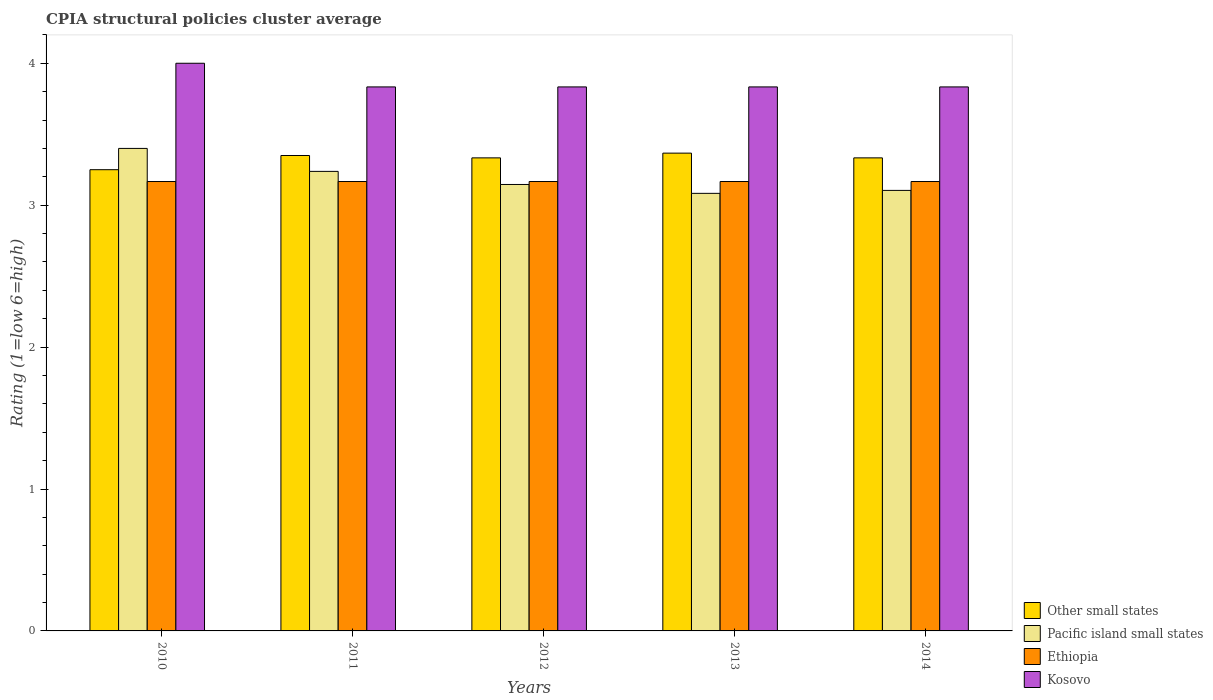How many different coloured bars are there?
Provide a short and direct response. 4. How many groups of bars are there?
Your answer should be compact. 5. How many bars are there on the 4th tick from the right?
Your answer should be compact. 4. What is the label of the 3rd group of bars from the left?
Your answer should be very brief. 2012. In how many cases, is the number of bars for a given year not equal to the number of legend labels?
Your answer should be compact. 0. What is the CPIA rating in Other small states in 2012?
Provide a succinct answer. 3.33. Across all years, what is the maximum CPIA rating in Kosovo?
Your answer should be very brief. 4. Across all years, what is the minimum CPIA rating in Pacific island small states?
Ensure brevity in your answer.  3.08. In which year was the CPIA rating in Ethiopia minimum?
Make the answer very short. 2010. What is the total CPIA rating in Other small states in the graph?
Your answer should be compact. 16.63. What is the difference between the CPIA rating in Ethiopia in 2011 and the CPIA rating in Kosovo in 2012?
Your answer should be very brief. -0.67. What is the average CPIA rating in Other small states per year?
Keep it short and to the point. 3.33. In the year 2011, what is the difference between the CPIA rating in Ethiopia and CPIA rating in Pacific island small states?
Provide a succinct answer. -0.07. In how many years, is the CPIA rating in Kosovo greater than 1.4?
Offer a terse response. 5. What is the ratio of the CPIA rating in Pacific island small states in 2012 to that in 2013?
Give a very brief answer. 1.02. Is the difference between the CPIA rating in Ethiopia in 2010 and 2013 greater than the difference between the CPIA rating in Pacific island small states in 2010 and 2013?
Give a very brief answer. No. What is the difference between the highest and the lowest CPIA rating in Kosovo?
Your answer should be very brief. 0.17. In how many years, is the CPIA rating in Kosovo greater than the average CPIA rating in Kosovo taken over all years?
Offer a very short reply. 1. Is the sum of the CPIA rating in Kosovo in 2011 and 2014 greater than the maximum CPIA rating in Ethiopia across all years?
Offer a very short reply. Yes. What does the 1st bar from the left in 2014 represents?
Make the answer very short. Other small states. What does the 1st bar from the right in 2012 represents?
Offer a terse response. Kosovo. Is it the case that in every year, the sum of the CPIA rating in Other small states and CPIA rating in Kosovo is greater than the CPIA rating in Ethiopia?
Offer a terse response. Yes. How many bars are there?
Offer a very short reply. 20. What is the difference between two consecutive major ticks on the Y-axis?
Your answer should be very brief. 1. Are the values on the major ticks of Y-axis written in scientific E-notation?
Make the answer very short. No. Does the graph contain grids?
Your answer should be very brief. No. Where does the legend appear in the graph?
Your response must be concise. Bottom right. How many legend labels are there?
Give a very brief answer. 4. How are the legend labels stacked?
Give a very brief answer. Vertical. What is the title of the graph?
Offer a very short reply. CPIA structural policies cluster average. Does "Congo (Democratic)" appear as one of the legend labels in the graph?
Make the answer very short. No. What is the label or title of the Y-axis?
Offer a terse response. Rating (1=low 6=high). What is the Rating (1=low 6=high) in Other small states in 2010?
Make the answer very short. 3.25. What is the Rating (1=low 6=high) of Ethiopia in 2010?
Ensure brevity in your answer.  3.17. What is the Rating (1=low 6=high) of Kosovo in 2010?
Ensure brevity in your answer.  4. What is the Rating (1=low 6=high) of Other small states in 2011?
Your answer should be compact. 3.35. What is the Rating (1=low 6=high) of Pacific island small states in 2011?
Provide a short and direct response. 3.24. What is the Rating (1=low 6=high) of Ethiopia in 2011?
Offer a terse response. 3.17. What is the Rating (1=low 6=high) of Kosovo in 2011?
Give a very brief answer. 3.83. What is the Rating (1=low 6=high) of Other small states in 2012?
Make the answer very short. 3.33. What is the Rating (1=low 6=high) in Pacific island small states in 2012?
Your response must be concise. 3.15. What is the Rating (1=low 6=high) in Ethiopia in 2012?
Your answer should be very brief. 3.17. What is the Rating (1=low 6=high) of Kosovo in 2012?
Provide a succinct answer. 3.83. What is the Rating (1=low 6=high) in Other small states in 2013?
Your response must be concise. 3.37. What is the Rating (1=low 6=high) of Pacific island small states in 2013?
Your answer should be very brief. 3.08. What is the Rating (1=low 6=high) in Ethiopia in 2013?
Keep it short and to the point. 3.17. What is the Rating (1=low 6=high) of Kosovo in 2013?
Offer a terse response. 3.83. What is the Rating (1=low 6=high) of Other small states in 2014?
Ensure brevity in your answer.  3.33. What is the Rating (1=low 6=high) in Pacific island small states in 2014?
Keep it short and to the point. 3.1. What is the Rating (1=low 6=high) in Ethiopia in 2014?
Offer a very short reply. 3.17. What is the Rating (1=low 6=high) in Kosovo in 2014?
Provide a short and direct response. 3.83. Across all years, what is the maximum Rating (1=low 6=high) in Other small states?
Your answer should be very brief. 3.37. Across all years, what is the maximum Rating (1=low 6=high) in Pacific island small states?
Offer a terse response. 3.4. Across all years, what is the maximum Rating (1=low 6=high) in Ethiopia?
Give a very brief answer. 3.17. Across all years, what is the minimum Rating (1=low 6=high) in Other small states?
Make the answer very short. 3.25. Across all years, what is the minimum Rating (1=low 6=high) of Pacific island small states?
Offer a terse response. 3.08. Across all years, what is the minimum Rating (1=low 6=high) of Ethiopia?
Offer a very short reply. 3.17. Across all years, what is the minimum Rating (1=low 6=high) of Kosovo?
Offer a terse response. 3.83. What is the total Rating (1=low 6=high) in Other small states in the graph?
Provide a succinct answer. 16.63. What is the total Rating (1=low 6=high) in Pacific island small states in the graph?
Offer a very short reply. 15.97. What is the total Rating (1=low 6=high) of Ethiopia in the graph?
Keep it short and to the point. 15.83. What is the total Rating (1=low 6=high) in Kosovo in the graph?
Make the answer very short. 19.33. What is the difference between the Rating (1=low 6=high) of Pacific island small states in 2010 and that in 2011?
Give a very brief answer. 0.16. What is the difference between the Rating (1=low 6=high) in Other small states in 2010 and that in 2012?
Ensure brevity in your answer.  -0.08. What is the difference between the Rating (1=low 6=high) in Pacific island small states in 2010 and that in 2012?
Your response must be concise. 0.25. What is the difference between the Rating (1=low 6=high) in Kosovo in 2010 and that in 2012?
Keep it short and to the point. 0.17. What is the difference between the Rating (1=low 6=high) of Other small states in 2010 and that in 2013?
Offer a terse response. -0.12. What is the difference between the Rating (1=low 6=high) in Pacific island small states in 2010 and that in 2013?
Provide a short and direct response. 0.32. What is the difference between the Rating (1=low 6=high) in Kosovo in 2010 and that in 2013?
Offer a very short reply. 0.17. What is the difference between the Rating (1=low 6=high) in Other small states in 2010 and that in 2014?
Offer a terse response. -0.08. What is the difference between the Rating (1=low 6=high) in Pacific island small states in 2010 and that in 2014?
Provide a short and direct response. 0.3. What is the difference between the Rating (1=low 6=high) of Kosovo in 2010 and that in 2014?
Provide a short and direct response. 0.17. What is the difference between the Rating (1=low 6=high) in Other small states in 2011 and that in 2012?
Offer a terse response. 0.02. What is the difference between the Rating (1=low 6=high) of Pacific island small states in 2011 and that in 2012?
Your answer should be compact. 0.09. What is the difference between the Rating (1=low 6=high) in Other small states in 2011 and that in 2013?
Offer a very short reply. -0.02. What is the difference between the Rating (1=low 6=high) in Pacific island small states in 2011 and that in 2013?
Ensure brevity in your answer.  0.15. What is the difference between the Rating (1=low 6=high) of Ethiopia in 2011 and that in 2013?
Your answer should be very brief. 0. What is the difference between the Rating (1=low 6=high) in Kosovo in 2011 and that in 2013?
Offer a very short reply. 0. What is the difference between the Rating (1=low 6=high) in Other small states in 2011 and that in 2014?
Offer a very short reply. 0.02. What is the difference between the Rating (1=low 6=high) in Pacific island small states in 2011 and that in 2014?
Your answer should be very brief. 0.13. What is the difference between the Rating (1=low 6=high) in Other small states in 2012 and that in 2013?
Offer a very short reply. -0.03. What is the difference between the Rating (1=low 6=high) of Pacific island small states in 2012 and that in 2013?
Offer a very short reply. 0.06. What is the difference between the Rating (1=low 6=high) of Ethiopia in 2012 and that in 2013?
Make the answer very short. 0. What is the difference between the Rating (1=low 6=high) of Kosovo in 2012 and that in 2013?
Ensure brevity in your answer.  0. What is the difference between the Rating (1=low 6=high) of Other small states in 2012 and that in 2014?
Your answer should be very brief. 0. What is the difference between the Rating (1=low 6=high) of Pacific island small states in 2012 and that in 2014?
Keep it short and to the point. 0.04. What is the difference between the Rating (1=low 6=high) in Ethiopia in 2012 and that in 2014?
Your answer should be compact. 0. What is the difference between the Rating (1=low 6=high) of Kosovo in 2012 and that in 2014?
Offer a very short reply. 0. What is the difference between the Rating (1=low 6=high) of Pacific island small states in 2013 and that in 2014?
Provide a short and direct response. -0.02. What is the difference between the Rating (1=low 6=high) in Other small states in 2010 and the Rating (1=low 6=high) in Pacific island small states in 2011?
Your answer should be very brief. 0.01. What is the difference between the Rating (1=low 6=high) of Other small states in 2010 and the Rating (1=low 6=high) of Ethiopia in 2011?
Provide a succinct answer. 0.08. What is the difference between the Rating (1=low 6=high) of Other small states in 2010 and the Rating (1=low 6=high) of Kosovo in 2011?
Your answer should be very brief. -0.58. What is the difference between the Rating (1=low 6=high) of Pacific island small states in 2010 and the Rating (1=low 6=high) of Ethiopia in 2011?
Your answer should be compact. 0.23. What is the difference between the Rating (1=low 6=high) in Pacific island small states in 2010 and the Rating (1=low 6=high) in Kosovo in 2011?
Keep it short and to the point. -0.43. What is the difference between the Rating (1=low 6=high) of Other small states in 2010 and the Rating (1=low 6=high) of Pacific island small states in 2012?
Offer a terse response. 0.1. What is the difference between the Rating (1=low 6=high) of Other small states in 2010 and the Rating (1=low 6=high) of Ethiopia in 2012?
Provide a short and direct response. 0.08. What is the difference between the Rating (1=low 6=high) of Other small states in 2010 and the Rating (1=low 6=high) of Kosovo in 2012?
Your answer should be very brief. -0.58. What is the difference between the Rating (1=low 6=high) of Pacific island small states in 2010 and the Rating (1=low 6=high) of Ethiopia in 2012?
Your answer should be very brief. 0.23. What is the difference between the Rating (1=low 6=high) of Pacific island small states in 2010 and the Rating (1=low 6=high) of Kosovo in 2012?
Provide a succinct answer. -0.43. What is the difference between the Rating (1=low 6=high) of Other small states in 2010 and the Rating (1=low 6=high) of Pacific island small states in 2013?
Your answer should be very brief. 0.17. What is the difference between the Rating (1=low 6=high) of Other small states in 2010 and the Rating (1=low 6=high) of Ethiopia in 2013?
Offer a very short reply. 0.08. What is the difference between the Rating (1=low 6=high) of Other small states in 2010 and the Rating (1=low 6=high) of Kosovo in 2013?
Make the answer very short. -0.58. What is the difference between the Rating (1=low 6=high) in Pacific island small states in 2010 and the Rating (1=low 6=high) in Ethiopia in 2013?
Keep it short and to the point. 0.23. What is the difference between the Rating (1=low 6=high) of Pacific island small states in 2010 and the Rating (1=low 6=high) of Kosovo in 2013?
Offer a terse response. -0.43. What is the difference between the Rating (1=low 6=high) of Other small states in 2010 and the Rating (1=low 6=high) of Pacific island small states in 2014?
Keep it short and to the point. 0.15. What is the difference between the Rating (1=low 6=high) of Other small states in 2010 and the Rating (1=low 6=high) of Ethiopia in 2014?
Provide a short and direct response. 0.08. What is the difference between the Rating (1=low 6=high) of Other small states in 2010 and the Rating (1=low 6=high) of Kosovo in 2014?
Offer a terse response. -0.58. What is the difference between the Rating (1=low 6=high) of Pacific island small states in 2010 and the Rating (1=low 6=high) of Ethiopia in 2014?
Your response must be concise. 0.23. What is the difference between the Rating (1=low 6=high) in Pacific island small states in 2010 and the Rating (1=low 6=high) in Kosovo in 2014?
Offer a very short reply. -0.43. What is the difference between the Rating (1=low 6=high) of Ethiopia in 2010 and the Rating (1=low 6=high) of Kosovo in 2014?
Your response must be concise. -0.67. What is the difference between the Rating (1=low 6=high) in Other small states in 2011 and the Rating (1=low 6=high) in Pacific island small states in 2012?
Offer a very short reply. 0.2. What is the difference between the Rating (1=low 6=high) in Other small states in 2011 and the Rating (1=low 6=high) in Ethiopia in 2012?
Give a very brief answer. 0.18. What is the difference between the Rating (1=low 6=high) in Other small states in 2011 and the Rating (1=low 6=high) in Kosovo in 2012?
Your answer should be very brief. -0.48. What is the difference between the Rating (1=low 6=high) of Pacific island small states in 2011 and the Rating (1=low 6=high) of Ethiopia in 2012?
Your response must be concise. 0.07. What is the difference between the Rating (1=low 6=high) in Pacific island small states in 2011 and the Rating (1=low 6=high) in Kosovo in 2012?
Your response must be concise. -0.6. What is the difference between the Rating (1=low 6=high) of Other small states in 2011 and the Rating (1=low 6=high) of Pacific island small states in 2013?
Provide a short and direct response. 0.27. What is the difference between the Rating (1=low 6=high) of Other small states in 2011 and the Rating (1=low 6=high) of Ethiopia in 2013?
Provide a succinct answer. 0.18. What is the difference between the Rating (1=low 6=high) of Other small states in 2011 and the Rating (1=low 6=high) of Kosovo in 2013?
Your answer should be compact. -0.48. What is the difference between the Rating (1=low 6=high) in Pacific island small states in 2011 and the Rating (1=low 6=high) in Ethiopia in 2013?
Offer a terse response. 0.07. What is the difference between the Rating (1=low 6=high) in Pacific island small states in 2011 and the Rating (1=low 6=high) in Kosovo in 2013?
Keep it short and to the point. -0.6. What is the difference between the Rating (1=low 6=high) in Other small states in 2011 and the Rating (1=low 6=high) in Pacific island small states in 2014?
Your response must be concise. 0.25. What is the difference between the Rating (1=low 6=high) in Other small states in 2011 and the Rating (1=low 6=high) in Ethiopia in 2014?
Your response must be concise. 0.18. What is the difference between the Rating (1=low 6=high) of Other small states in 2011 and the Rating (1=low 6=high) of Kosovo in 2014?
Your answer should be compact. -0.48. What is the difference between the Rating (1=low 6=high) in Pacific island small states in 2011 and the Rating (1=low 6=high) in Ethiopia in 2014?
Your answer should be very brief. 0.07. What is the difference between the Rating (1=low 6=high) in Pacific island small states in 2011 and the Rating (1=low 6=high) in Kosovo in 2014?
Keep it short and to the point. -0.6. What is the difference between the Rating (1=low 6=high) of Ethiopia in 2011 and the Rating (1=low 6=high) of Kosovo in 2014?
Keep it short and to the point. -0.67. What is the difference between the Rating (1=low 6=high) of Other small states in 2012 and the Rating (1=low 6=high) of Kosovo in 2013?
Your answer should be compact. -0.5. What is the difference between the Rating (1=low 6=high) of Pacific island small states in 2012 and the Rating (1=low 6=high) of Ethiopia in 2013?
Ensure brevity in your answer.  -0.02. What is the difference between the Rating (1=low 6=high) in Pacific island small states in 2012 and the Rating (1=low 6=high) in Kosovo in 2013?
Offer a terse response. -0.69. What is the difference between the Rating (1=low 6=high) of Ethiopia in 2012 and the Rating (1=low 6=high) of Kosovo in 2013?
Your answer should be compact. -0.67. What is the difference between the Rating (1=low 6=high) of Other small states in 2012 and the Rating (1=low 6=high) of Pacific island small states in 2014?
Offer a terse response. 0.23. What is the difference between the Rating (1=low 6=high) in Other small states in 2012 and the Rating (1=low 6=high) in Ethiopia in 2014?
Keep it short and to the point. 0.17. What is the difference between the Rating (1=low 6=high) of Pacific island small states in 2012 and the Rating (1=low 6=high) of Ethiopia in 2014?
Make the answer very short. -0.02. What is the difference between the Rating (1=low 6=high) in Pacific island small states in 2012 and the Rating (1=low 6=high) in Kosovo in 2014?
Ensure brevity in your answer.  -0.69. What is the difference between the Rating (1=low 6=high) in Other small states in 2013 and the Rating (1=low 6=high) in Pacific island small states in 2014?
Your response must be concise. 0.26. What is the difference between the Rating (1=low 6=high) in Other small states in 2013 and the Rating (1=low 6=high) in Kosovo in 2014?
Give a very brief answer. -0.47. What is the difference between the Rating (1=low 6=high) in Pacific island small states in 2013 and the Rating (1=low 6=high) in Ethiopia in 2014?
Give a very brief answer. -0.08. What is the difference between the Rating (1=low 6=high) in Pacific island small states in 2013 and the Rating (1=low 6=high) in Kosovo in 2014?
Offer a very short reply. -0.75. What is the difference between the Rating (1=low 6=high) in Ethiopia in 2013 and the Rating (1=low 6=high) in Kosovo in 2014?
Provide a short and direct response. -0.67. What is the average Rating (1=low 6=high) in Other small states per year?
Your answer should be compact. 3.33. What is the average Rating (1=low 6=high) in Pacific island small states per year?
Your answer should be very brief. 3.19. What is the average Rating (1=low 6=high) of Ethiopia per year?
Offer a terse response. 3.17. What is the average Rating (1=low 6=high) in Kosovo per year?
Ensure brevity in your answer.  3.87. In the year 2010, what is the difference between the Rating (1=low 6=high) in Other small states and Rating (1=low 6=high) in Pacific island small states?
Keep it short and to the point. -0.15. In the year 2010, what is the difference between the Rating (1=low 6=high) in Other small states and Rating (1=low 6=high) in Ethiopia?
Your response must be concise. 0.08. In the year 2010, what is the difference between the Rating (1=low 6=high) in Other small states and Rating (1=low 6=high) in Kosovo?
Your answer should be very brief. -0.75. In the year 2010, what is the difference between the Rating (1=low 6=high) in Pacific island small states and Rating (1=low 6=high) in Ethiopia?
Offer a terse response. 0.23. In the year 2010, what is the difference between the Rating (1=low 6=high) of Pacific island small states and Rating (1=low 6=high) of Kosovo?
Provide a short and direct response. -0.6. In the year 2010, what is the difference between the Rating (1=low 6=high) in Ethiopia and Rating (1=low 6=high) in Kosovo?
Give a very brief answer. -0.83. In the year 2011, what is the difference between the Rating (1=low 6=high) of Other small states and Rating (1=low 6=high) of Pacific island small states?
Keep it short and to the point. 0.11. In the year 2011, what is the difference between the Rating (1=low 6=high) in Other small states and Rating (1=low 6=high) in Ethiopia?
Offer a terse response. 0.18. In the year 2011, what is the difference between the Rating (1=low 6=high) in Other small states and Rating (1=low 6=high) in Kosovo?
Provide a short and direct response. -0.48. In the year 2011, what is the difference between the Rating (1=low 6=high) in Pacific island small states and Rating (1=low 6=high) in Ethiopia?
Your answer should be compact. 0.07. In the year 2011, what is the difference between the Rating (1=low 6=high) in Pacific island small states and Rating (1=low 6=high) in Kosovo?
Ensure brevity in your answer.  -0.6. In the year 2011, what is the difference between the Rating (1=low 6=high) in Ethiopia and Rating (1=low 6=high) in Kosovo?
Give a very brief answer. -0.67. In the year 2012, what is the difference between the Rating (1=low 6=high) in Other small states and Rating (1=low 6=high) in Pacific island small states?
Provide a short and direct response. 0.19. In the year 2012, what is the difference between the Rating (1=low 6=high) of Other small states and Rating (1=low 6=high) of Ethiopia?
Provide a succinct answer. 0.17. In the year 2012, what is the difference between the Rating (1=low 6=high) of Other small states and Rating (1=low 6=high) of Kosovo?
Keep it short and to the point. -0.5. In the year 2012, what is the difference between the Rating (1=low 6=high) of Pacific island small states and Rating (1=low 6=high) of Ethiopia?
Offer a very short reply. -0.02. In the year 2012, what is the difference between the Rating (1=low 6=high) of Pacific island small states and Rating (1=low 6=high) of Kosovo?
Provide a short and direct response. -0.69. In the year 2013, what is the difference between the Rating (1=low 6=high) in Other small states and Rating (1=low 6=high) in Pacific island small states?
Provide a short and direct response. 0.28. In the year 2013, what is the difference between the Rating (1=low 6=high) in Other small states and Rating (1=low 6=high) in Ethiopia?
Give a very brief answer. 0.2. In the year 2013, what is the difference between the Rating (1=low 6=high) in Other small states and Rating (1=low 6=high) in Kosovo?
Ensure brevity in your answer.  -0.47. In the year 2013, what is the difference between the Rating (1=low 6=high) in Pacific island small states and Rating (1=low 6=high) in Ethiopia?
Your response must be concise. -0.08. In the year 2013, what is the difference between the Rating (1=low 6=high) in Pacific island small states and Rating (1=low 6=high) in Kosovo?
Keep it short and to the point. -0.75. In the year 2013, what is the difference between the Rating (1=low 6=high) of Ethiopia and Rating (1=low 6=high) of Kosovo?
Offer a very short reply. -0.67. In the year 2014, what is the difference between the Rating (1=low 6=high) in Other small states and Rating (1=low 6=high) in Pacific island small states?
Provide a short and direct response. 0.23. In the year 2014, what is the difference between the Rating (1=low 6=high) in Pacific island small states and Rating (1=low 6=high) in Ethiopia?
Make the answer very short. -0.06. In the year 2014, what is the difference between the Rating (1=low 6=high) of Pacific island small states and Rating (1=low 6=high) of Kosovo?
Offer a very short reply. -0.73. In the year 2014, what is the difference between the Rating (1=low 6=high) in Ethiopia and Rating (1=low 6=high) in Kosovo?
Your response must be concise. -0.67. What is the ratio of the Rating (1=low 6=high) in Other small states in 2010 to that in 2011?
Provide a short and direct response. 0.97. What is the ratio of the Rating (1=low 6=high) in Kosovo in 2010 to that in 2011?
Your response must be concise. 1.04. What is the ratio of the Rating (1=low 6=high) of Pacific island small states in 2010 to that in 2012?
Give a very brief answer. 1.08. What is the ratio of the Rating (1=low 6=high) of Ethiopia in 2010 to that in 2012?
Your response must be concise. 1. What is the ratio of the Rating (1=low 6=high) of Kosovo in 2010 to that in 2012?
Offer a terse response. 1.04. What is the ratio of the Rating (1=low 6=high) of Other small states in 2010 to that in 2013?
Provide a succinct answer. 0.97. What is the ratio of the Rating (1=low 6=high) of Pacific island small states in 2010 to that in 2013?
Your answer should be very brief. 1.1. What is the ratio of the Rating (1=low 6=high) of Kosovo in 2010 to that in 2013?
Ensure brevity in your answer.  1.04. What is the ratio of the Rating (1=low 6=high) in Pacific island small states in 2010 to that in 2014?
Keep it short and to the point. 1.1. What is the ratio of the Rating (1=low 6=high) of Kosovo in 2010 to that in 2014?
Provide a short and direct response. 1.04. What is the ratio of the Rating (1=low 6=high) of Pacific island small states in 2011 to that in 2012?
Keep it short and to the point. 1.03. What is the ratio of the Rating (1=low 6=high) in Ethiopia in 2011 to that in 2012?
Ensure brevity in your answer.  1. What is the ratio of the Rating (1=low 6=high) in Pacific island small states in 2011 to that in 2013?
Offer a terse response. 1.05. What is the ratio of the Rating (1=low 6=high) in Ethiopia in 2011 to that in 2013?
Offer a very short reply. 1. What is the ratio of the Rating (1=low 6=high) in Other small states in 2011 to that in 2014?
Your response must be concise. 1. What is the ratio of the Rating (1=low 6=high) in Pacific island small states in 2011 to that in 2014?
Keep it short and to the point. 1.04. What is the ratio of the Rating (1=low 6=high) in Kosovo in 2011 to that in 2014?
Offer a very short reply. 1. What is the ratio of the Rating (1=low 6=high) of Pacific island small states in 2012 to that in 2013?
Provide a short and direct response. 1.02. What is the ratio of the Rating (1=low 6=high) in Kosovo in 2012 to that in 2013?
Your answer should be very brief. 1. What is the ratio of the Rating (1=low 6=high) in Other small states in 2012 to that in 2014?
Offer a very short reply. 1. What is the ratio of the Rating (1=low 6=high) in Pacific island small states in 2012 to that in 2014?
Provide a succinct answer. 1.01. What is the ratio of the Rating (1=low 6=high) in Kosovo in 2012 to that in 2014?
Provide a succinct answer. 1. What is the ratio of the Rating (1=low 6=high) in Ethiopia in 2013 to that in 2014?
Make the answer very short. 1. What is the ratio of the Rating (1=low 6=high) of Kosovo in 2013 to that in 2014?
Your response must be concise. 1. What is the difference between the highest and the second highest Rating (1=low 6=high) in Other small states?
Give a very brief answer. 0.02. What is the difference between the highest and the second highest Rating (1=low 6=high) of Pacific island small states?
Offer a very short reply. 0.16. What is the difference between the highest and the second highest Rating (1=low 6=high) of Ethiopia?
Give a very brief answer. 0. What is the difference between the highest and the lowest Rating (1=low 6=high) of Other small states?
Your answer should be very brief. 0.12. What is the difference between the highest and the lowest Rating (1=low 6=high) in Pacific island small states?
Provide a short and direct response. 0.32. What is the difference between the highest and the lowest Rating (1=low 6=high) of Ethiopia?
Provide a succinct answer. 0. 